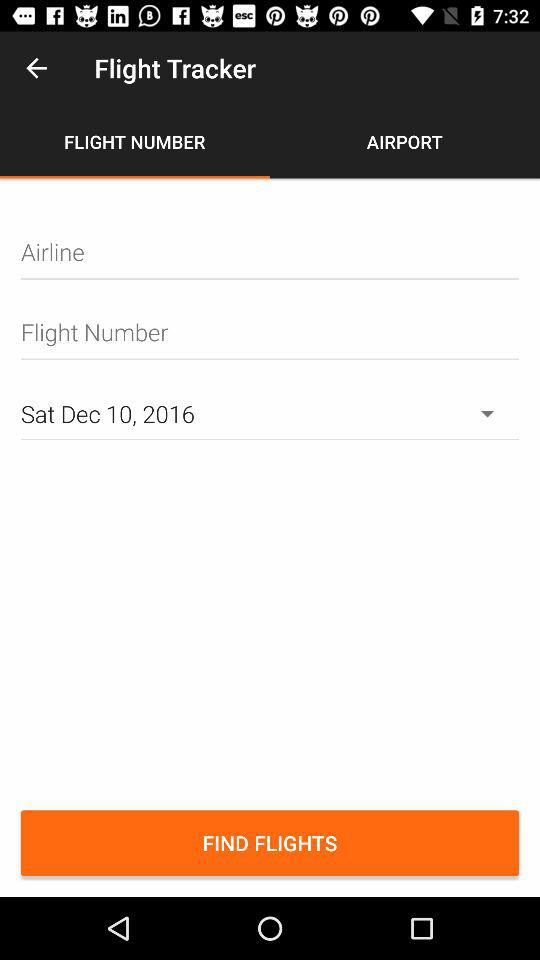Which option is selected for the "Flight Tracker"? The selected option is "FLIGHT NUMBER". 